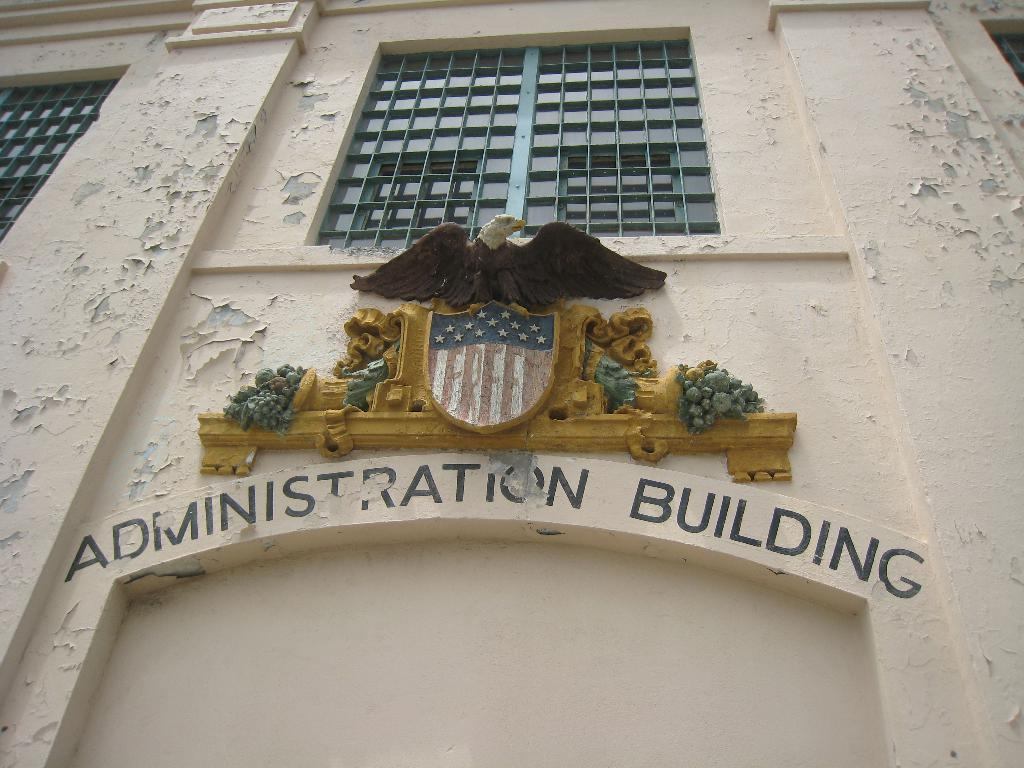What is written or displayed on the building in the image? There is text on a building in the image. What type of material is used for the rods visible in the image? Metal rods are visible in the image. Who is the manager of the field in the image? There is no field or manager present in the image. What type of yarn is being used to create the text on the building? The text on the building is not created with yarn; it is likely painted or displayed using another method. 